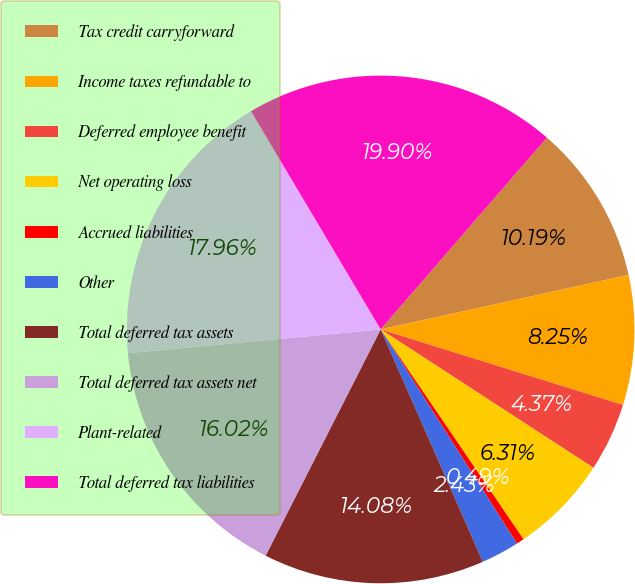Convert chart to OTSL. <chart><loc_0><loc_0><loc_500><loc_500><pie_chart><fcel>Tax credit carryforward<fcel>Income taxes refundable to<fcel>Deferred employee benefit<fcel>Net operating loss<fcel>Accrued liabilities<fcel>Other<fcel>Total deferred tax assets<fcel>Total deferred tax assets net<fcel>Plant-related<fcel>Total deferred tax liabilities<nl><fcel>10.19%<fcel>8.25%<fcel>4.37%<fcel>6.31%<fcel>0.49%<fcel>2.43%<fcel>14.08%<fcel>16.02%<fcel>17.96%<fcel>19.9%<nl></chart> 